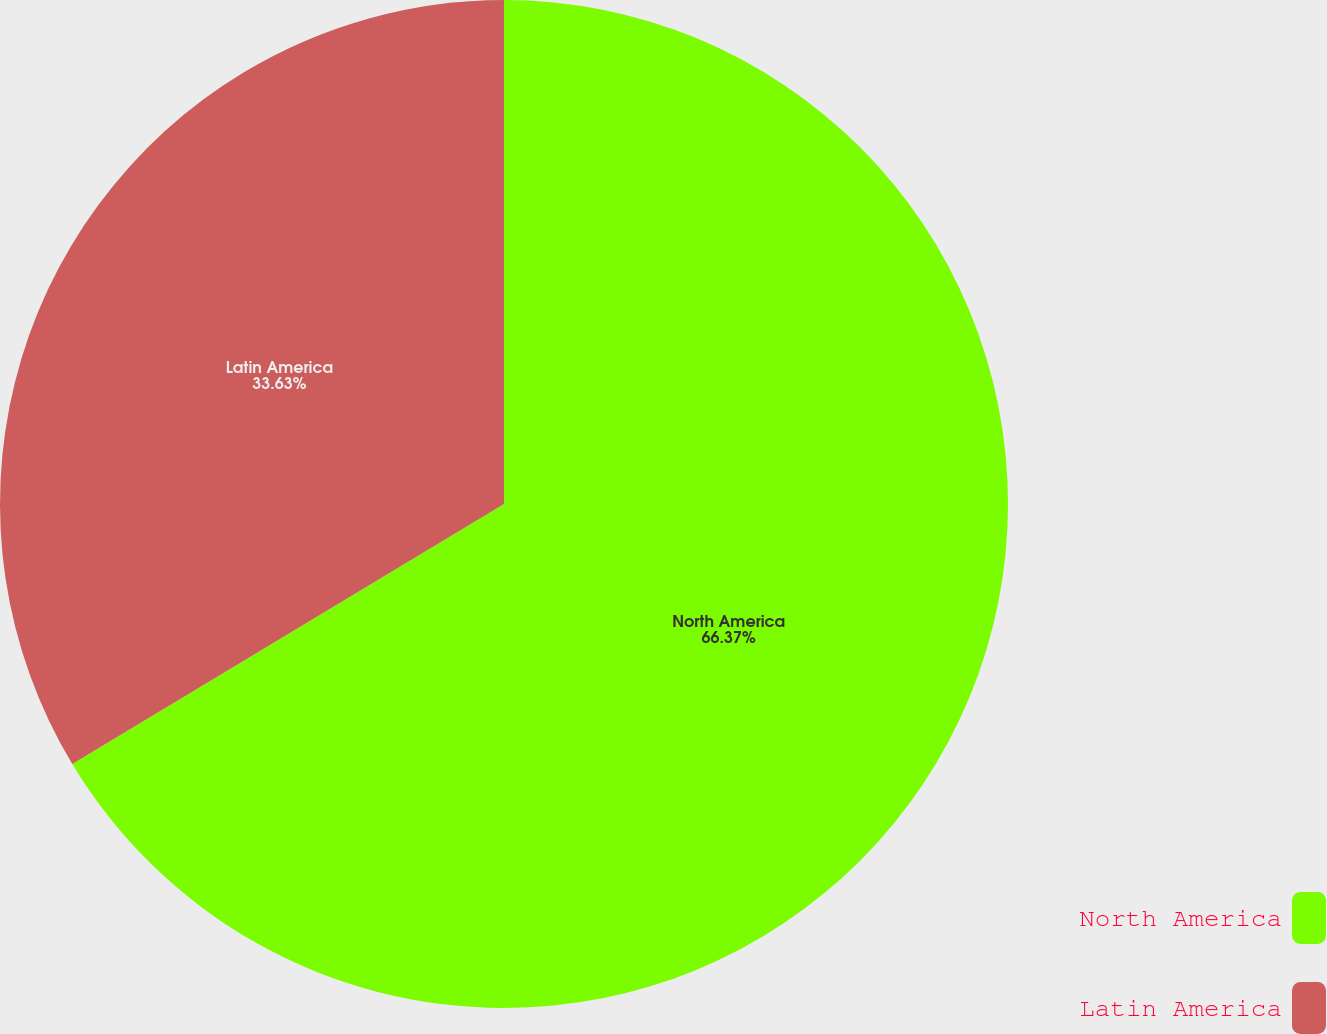Convert chart to OTSL. <chart><loc_0><loc_0><loc_500><loc_500><pie_chart><fcel>North America<fcel>Latin America<nl><fcel>66.37%<fcel>33.63%<nl></chart> 